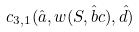<formula> <loc_0><loc_0><loc_500><loc_500>c _ { 3 , 1 } ( \hat { a } , w ( S , \hat { b } c ) , \hat { d } )</formula> 